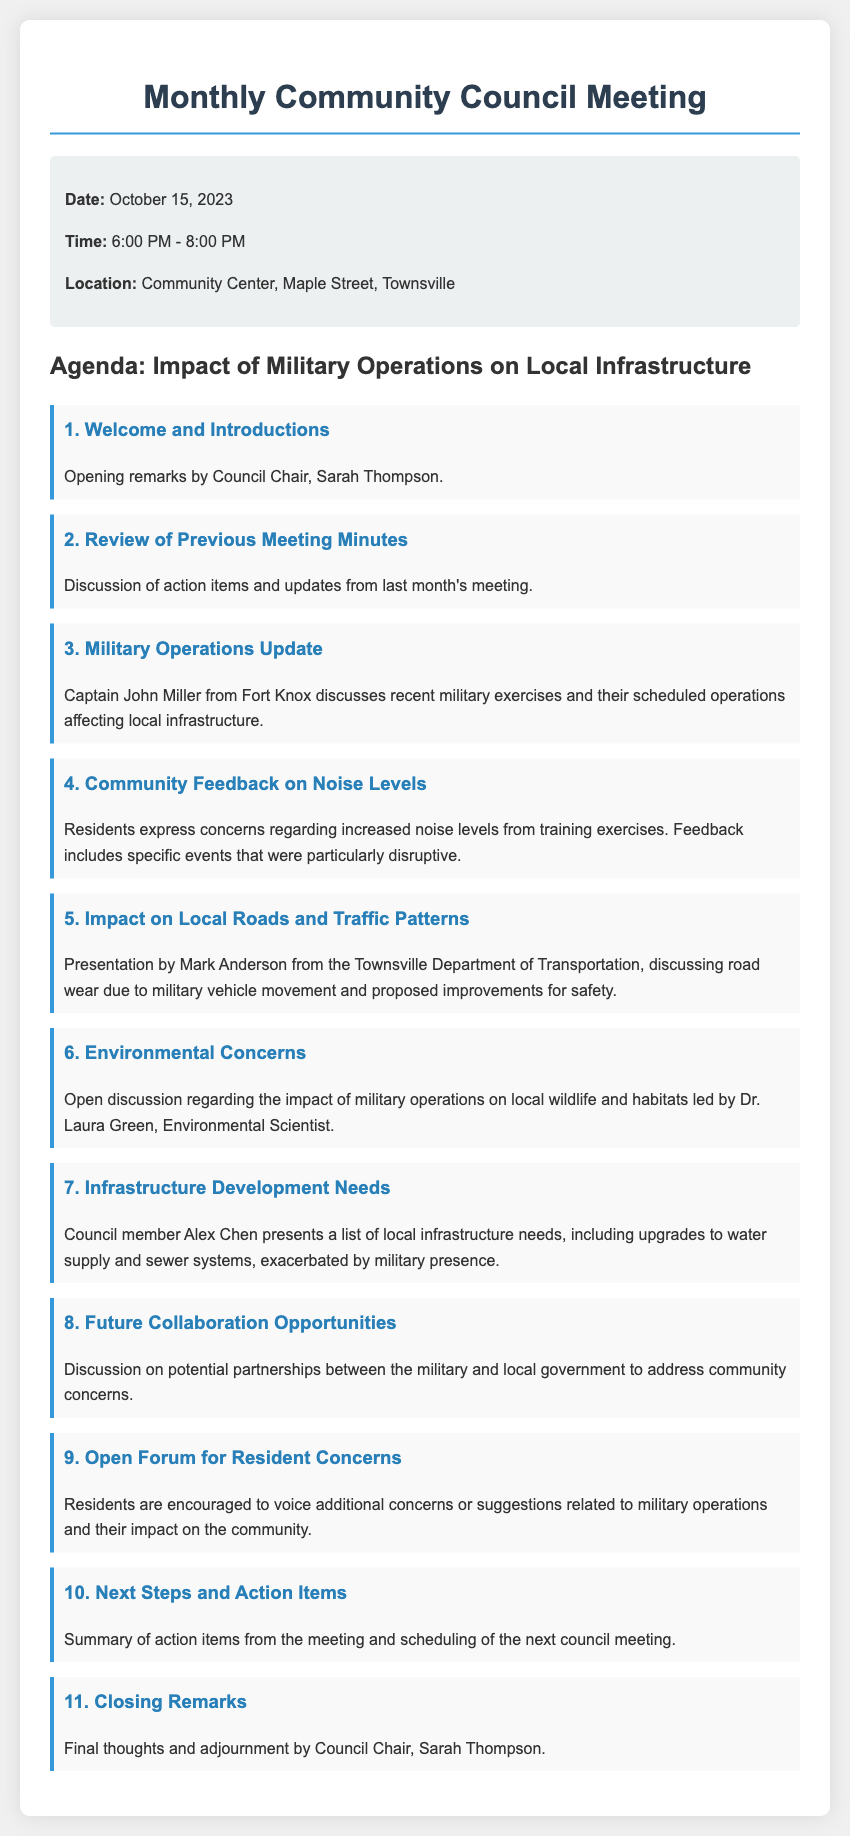What is the date of the meeting? The date of the meeting is explicitly stated as October 15, 2023.
Answer: October 15, 2023 Who opens the meeting? The opening remarks are made by Council Chair, Sarah Thompson, mentioned in the agenda.
Answer: Sarah Thompson What is the main topic of discussion? The agenda specifies that the main topic is the impact of military operations on local infrastructure.
Answer: Impact of Military Operations on Local Infrastructure Which council member presents infrastructure needs? Council member Alex Chen is noted for presenting local infrastructure needs during the meeting.
Answer: Alex Chen What does Captain John Miller provide an update on? Captain John Miller discusses recent military exercises and operations affecting local infrastructure.
Answer: Military Operations Update What specific problem is discussed regarding noise? Residents express concerns regarding increased noise levels from training exercises, which is highlighted as an issue.
Answer: Increased noise levels How many agenda items are there? The document lists a total of 11 agenda items for the meeting.
Answer: 11 Who leads the discussion on environmental concerns? The open discussion on environmental concerns is led by Dr. Laura Green, an Environmental Scientist.
Answer: Dr. Laura Green When does the meeting take place? The document states that the meeting takes place from 6:00 PM to 8:00 PM.
Answer: 6:00 PM - 8:00 PM 